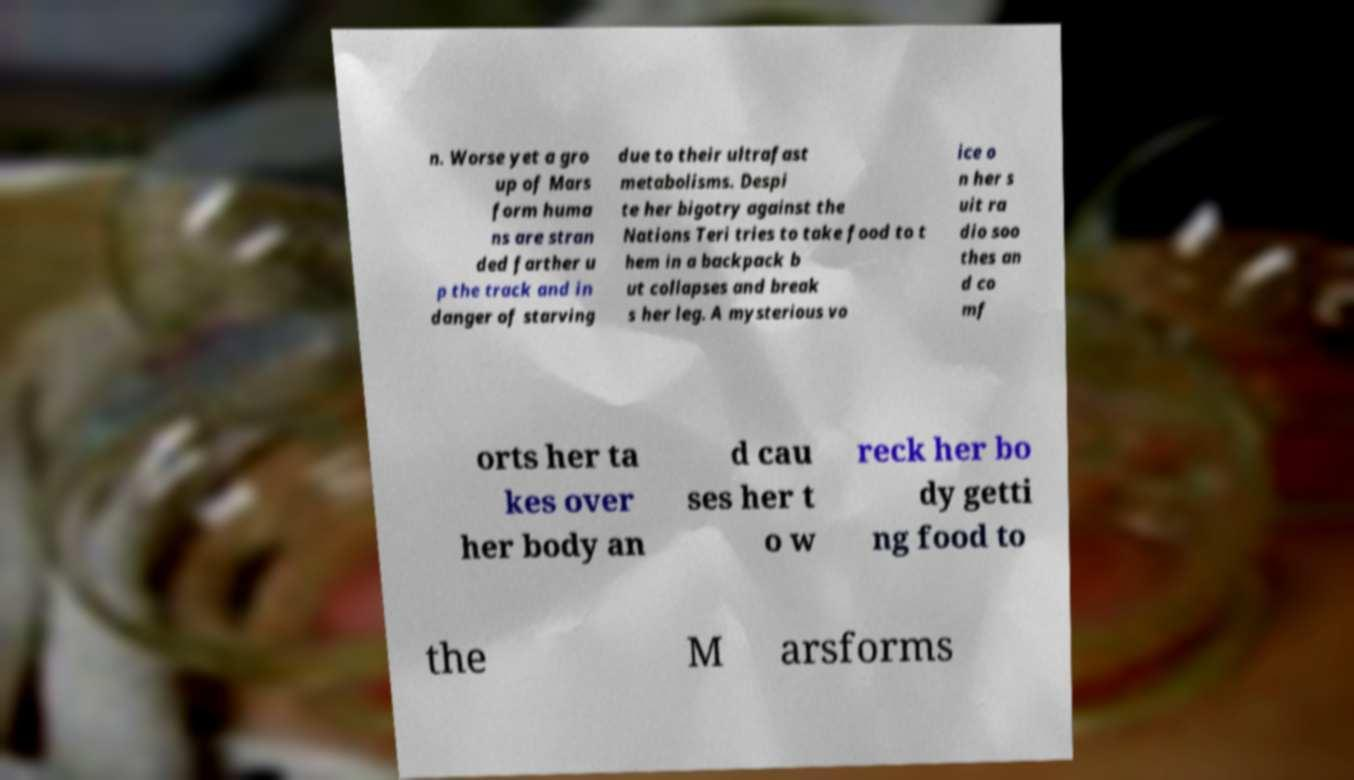Please identify and transcribe the text found in this image. n. Worse yet a gro up of Mars form huma ns are stran ded farther u p the track and in danger of starving due to their ultrafast metabolisms. Despi te her bigotry against the Nations Teri tries to take food to t hem in a backpack b ut collapses and break s her leg. A mysterious vo ice o n her s uit ra dio soo thes an d co mf orts her ta kes over her body an d cau ses her t o w reck her bo dy getti ng food to the M arsforms 